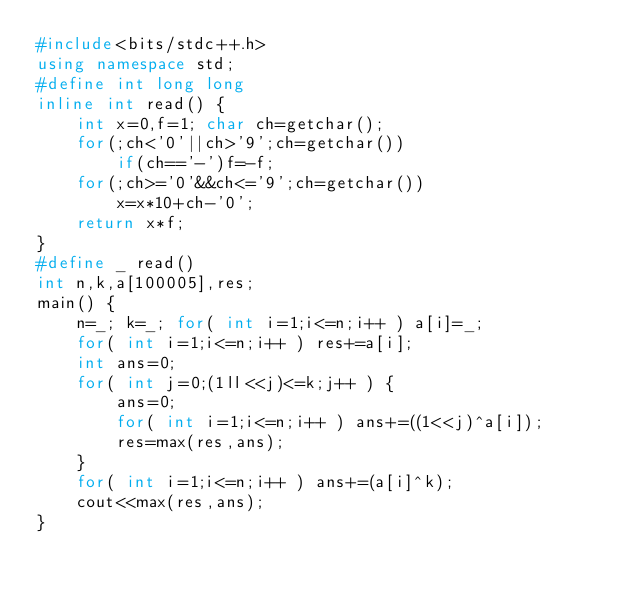Convert code to text. <code><loc_0><loc_0><loc_500><loc_500><_C++_>#include<bits/stdc++.h>
using namespace std;
#define int long long
inline int read() {
	int x=0,f=1; char ch=getchar();
	for(;ch<'0'||ch>'9';ch=getchar())
		if(ch=='-')f=-f;
	for(;ch>='0'&&ch<='9';ch=getchar())
		x=x*10+ch-'0';
	return x*f;
}
#define _ read()
int n,k,a[100005],res;
main() {
	n=_; k=_; for( int i=1;i<=n;i++ ) a[i]=_;
	for( int i=1;i<=n;i++ ) res+=a[i]; 
	int ans=0;
	for( int j=0;(1ll<<j)<=k;j++ ) {
		ans=0;
		for( int i=1;i<=n;i++ ) ans+=((1<<j)^a[i]);
		res=max(res,ans);
	}
	for( int i=1;i<=n;i++ ) ans+=(a[i]^k);
	cout<<max(res,ans);
}</code> 